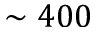Convert formula to latex. <formula><loc_0><loc_0><loc_500><loc_500>\sim 4 0 0</formula> 